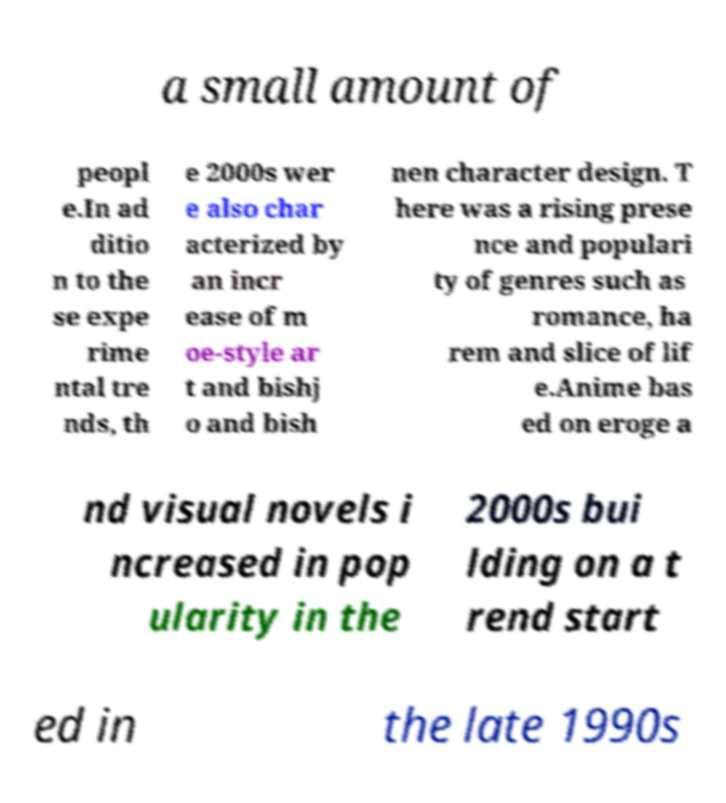Can you read and provide the text displayed in the image?This photo seems to have some interesting text. Can you extract and type it out for me? a small amount of peopl e.In ad ditio n to the se expe rime ntal tre nds, th e 2000s wer e also char acterized by an incr ease of m oe-style ar t and bishj o and bish nen character design. T here was a rising prese nce and populari ty of genres such as romance, ha rem and slice of lif e.Anime bas ed on eroge a nd visual novels i ncreased in pop ularity in the 2000s bui lding on a t rend start ed in the late 1990s 